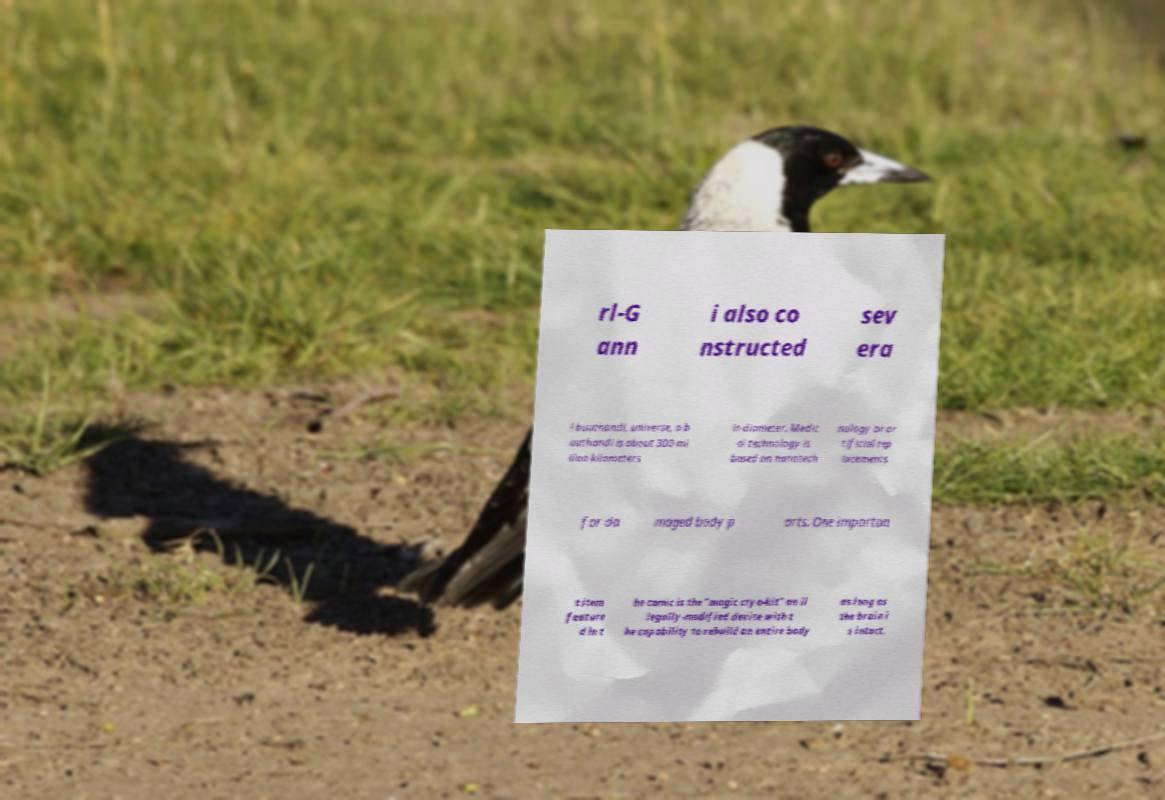There's text embedded in this image that I need extracted. Can you transcribe it verbatim? rl-G ann i also co nstructed sev era l buuthandi, universe, a b uuthandi is about 300 mi llion kilometers in diameter. Medic al technology is based on nanotech nology or ar tificial rep lacements for da maged body p arts. One importan t item feature d in t he comic is the "magic cryo-kit" an il legally-modified device with t he capability to rebuild an entire body as long as the brain i s intact. 